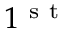<formula> <loc_0><loc_0><loc_500><loc_500>1 ^ { s t }</formula> 